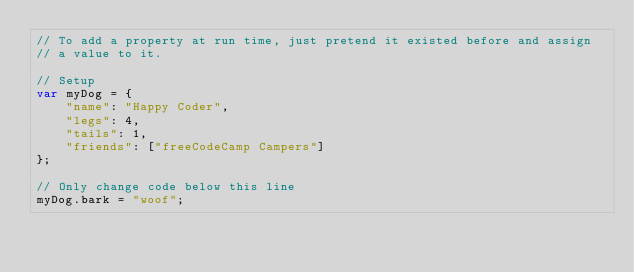Convert code to text. <code><loc_0><loc_0><loc_500><loc_500><_JavaScript_>// To add a property at run time, just pretend it existed before and assign
// a value to it.

// Setup
var myDog = {
    "name": "Happy Coder",
    "legs": 4,
    "tails": 1,
    "friends": ["freeCodeCamp Campers"]
};

// Only change code below this line
myDog.bark = "woof";
</code> 